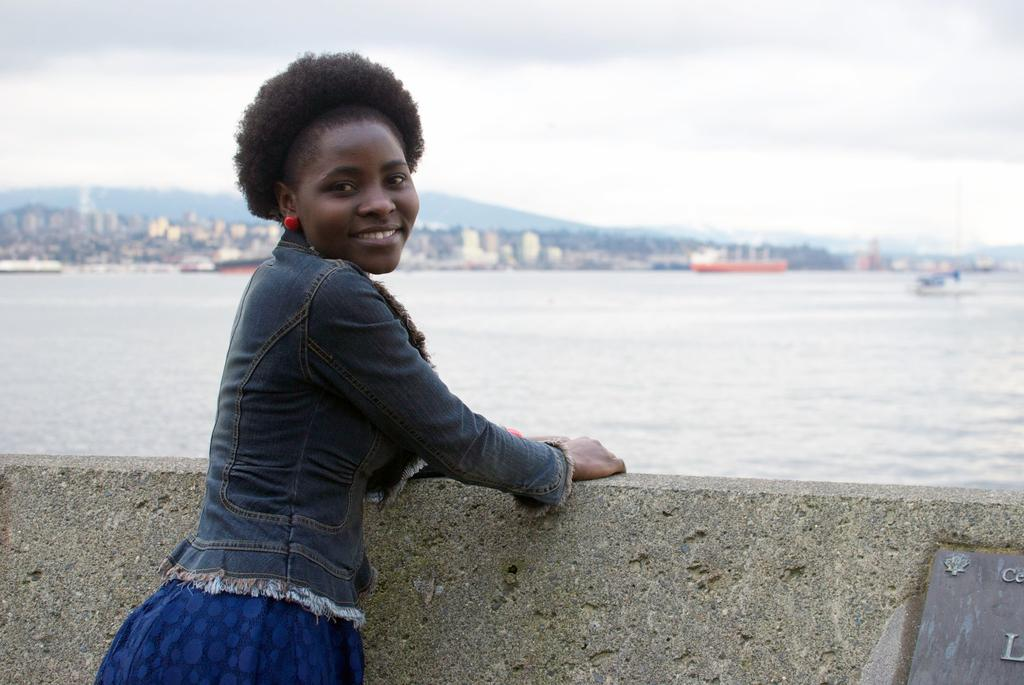What is the woman doing in the image? The woman is standing near a wall in the image. What can be seen in the background of the image? Water, buildings, a mountain, and the sky are visible in the background of the image. Can you describe the natural landscape in the image? The image features a mountain in the background, indicating a natural landscape. What type of friction is the woman experiencing while standing near the wall? There is no information about the woman's experience of friction in the image, as it does not provide details about her physical interaction with the wall. 